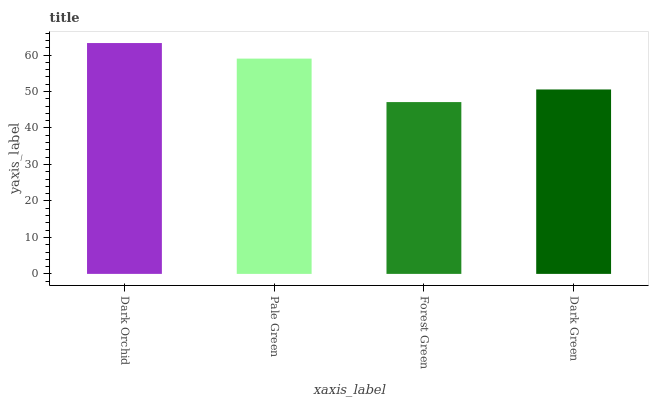Is Pale Green the minimum?
Answer yes or no. No. Is Pale Green the maximum?
Answer yes or no. No. Is Dark Orchid greater than Pale Green?
Answer yes or no. Yes. Is Pale Green less than Dark Orchid?
Answer yes or no. Yes. Is Pale Green greater than Dark Orchid?
Answer yes or no. No. Is Dark Orchid less than Pale Green?
Answer yes or no. No. Is Pale Green the high median?
Answer yes or no. Yes. Is Dark Green the low median?
Answer yes or no. Yes. Is Forest Green the high median?
Answer yes or no. No. Is Dark Orchid the low median?
Answer yes or no. No. 